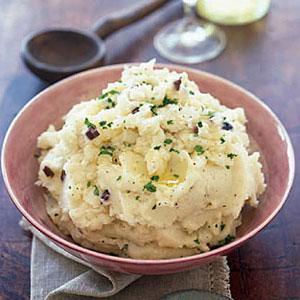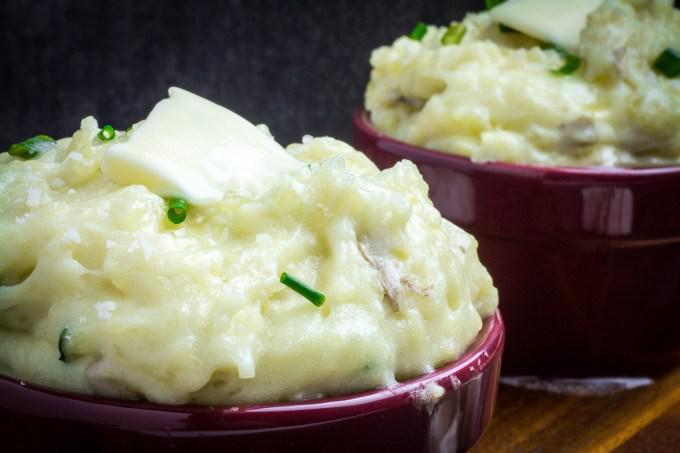The first image is the image on the left, the second image is the image on the right. Analyze the images presented: Is the assertion "One image shows two servings of mashed potatoes in purple bowls." valid? Answer yes or no. Yes. 